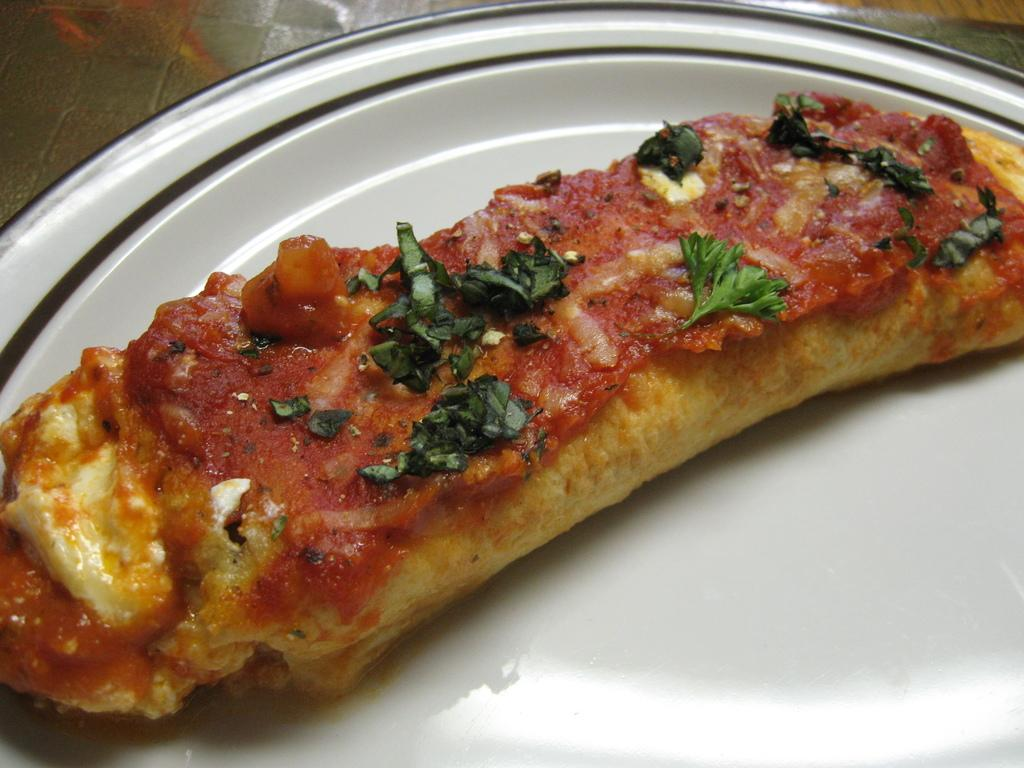What is on the plate that is visible in the image? The plate contains an edible item. Can you describe the color of the plate? The plate is white. What might be the surface that the plate is resting on? There is a grey area in the top left corner of the image, which may represent the floor. How does the wire connect to the example of wealth in the image? There is no wire or example of wealth present in the image. 